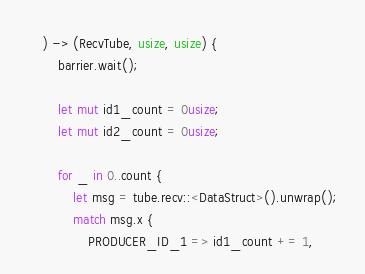<code> <loc_0><loc_0><loc_500><loc_500><_Rust_>    ) -> (RecvTube, usize, usize) {
        barrier.wait();

        let mut id1_count = 0usize;
        let mut id2_count = 0usize;

        for _ in 0..count {
            let msg = tube.recv::<DataStruct>().unwrap();
            match msg.x {
                PRODUCER_ID_1 => id1_count += 1,</code> 